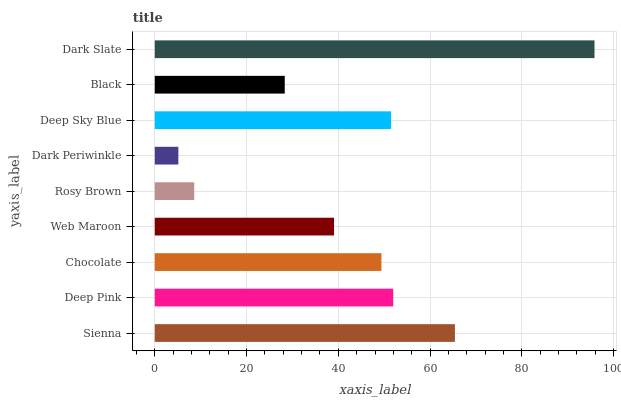Is Dark Periwinkle the minimum?
Answer yes or no. Yes. Is Dark Slate the maximum?
Answer yes or no. Yes. Is Deep Pink the minimum?
Answer yes or no. No. Is Deep Pink the maximum?
Answer yes or no. No. Is Sienna greater than Deep Pink?
Answer yes or no. Yes. Is Deep Pink less than Sienna?
Answer yes or no. Yes. Is Deep Pink greater than Sienna?
Answer yes or no. No. Is Sienna less than Deep Pink?
Answer yes or no. No. Is Chocolate the high median?
Answer yes or no. Yes. Is Chocolate the low median?
Answer yes or no. Yes. Is Deep Sky Blue the high median?
Answer yes or no. No. Is Deep Sky Blue the low median?
Answer yes or no. No. 